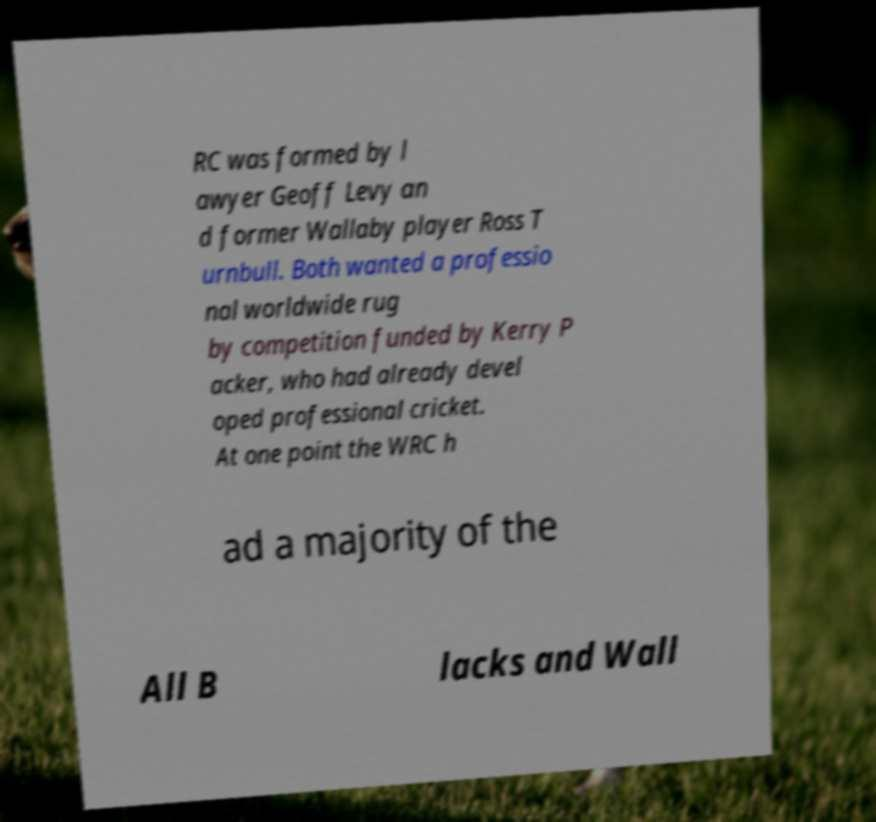There's text embedded in this image that I need extracted. Can you transcribe it verbatim? RC was formed by l awyer Geoff Levy an d former Wallaby player Ross T urnbull. Both wanted a professio nal worldwide rug by competition funded by Kerry P acker, who had already devel oped professional cricket. At one point the WRC h ad a majority of the All B lacks and Wall 